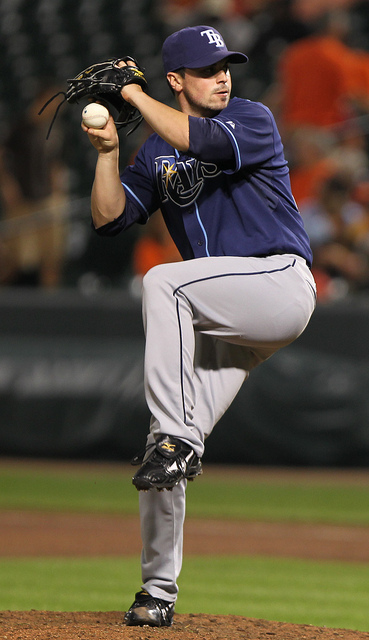Please transcribe the text in this image. TB RAYS 